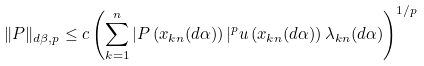Convert formula to latex. <formula><loc_0><loc_0><loc_500><loc_500>\| P \| _ { d \beta , p } \leq c \left ( \sum _ { k = 1 } ^ { n } | P \left ( x _ { k n } ( d \alpha ) \right ) | ^ { p } u \left ( x _ { k n } ( d \alpha ) \right ) \lambda _ { k n } ( d \alpha ) \right ) ^ { 1 / p }</formula> 